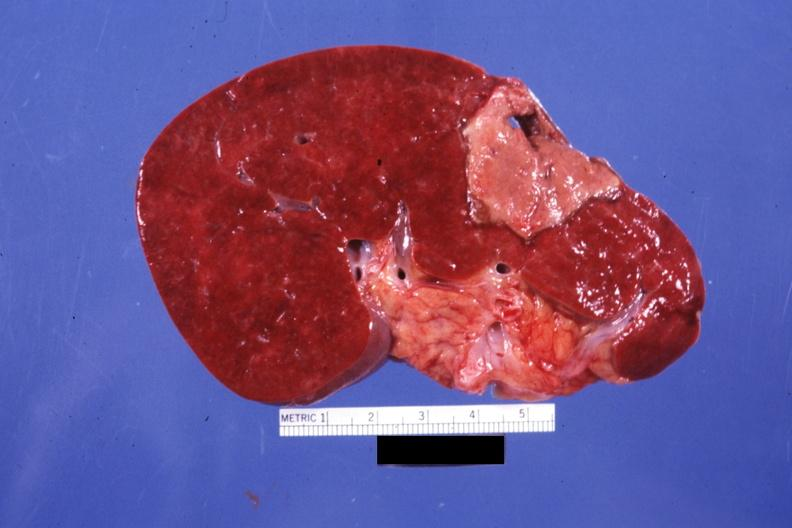where is this part in?
Answer the question using a single word or phrase. Spleen 